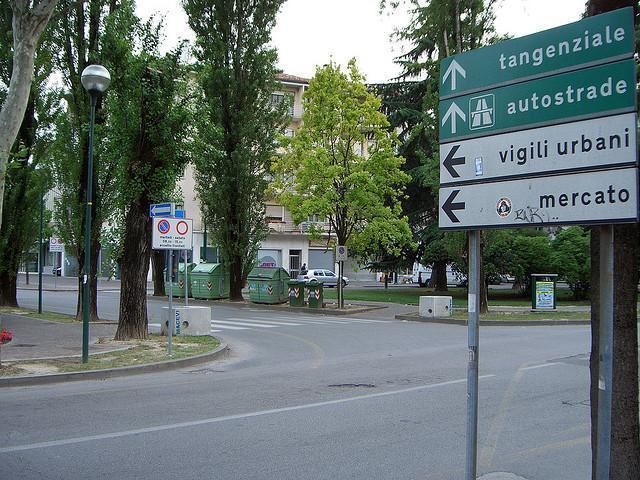How many horses are there?
Give a very brief answer. 0. 